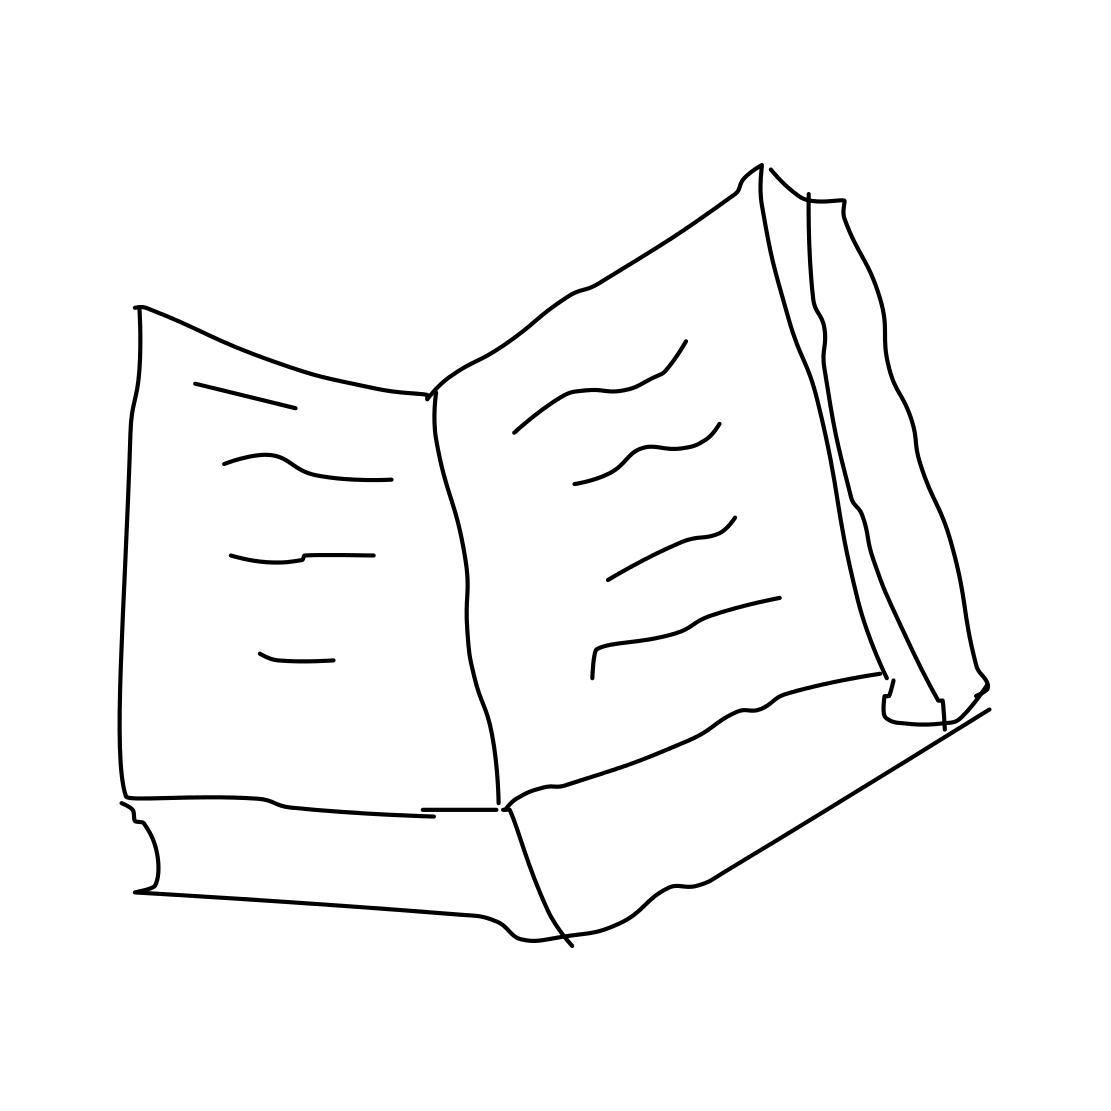Is this a book in the image? Yes 